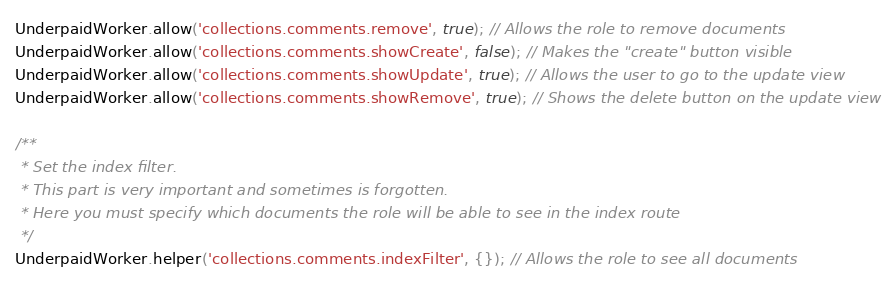Convert code to text. <code><loc_0><loc_0><loc_500><loc_500><_JavaScript_>UnderpaidWorker.allow('collections.comments.remove', true); // Allows the role to remove documents
UnderpaidWorker.allow('collections.comments.showCreate', false); // Makes the "create" button visible
UnderpaidWorker.allow('collections.comments.showUpdate', true); // Allows the user to go to the update view
UnderpaidWorker.allow('collections.comments.showRemove', true); // Shows the delete button on the update view

/**
 * Set the index filter.
 * This part is very important and sometimes is forgotten.
 * Here you must specify which documents the role will be able to see in the index route
 */
UnderpaidWorker.helper('collections.comments.indexFilter', {}); // Allows the role to see all documents</code> 